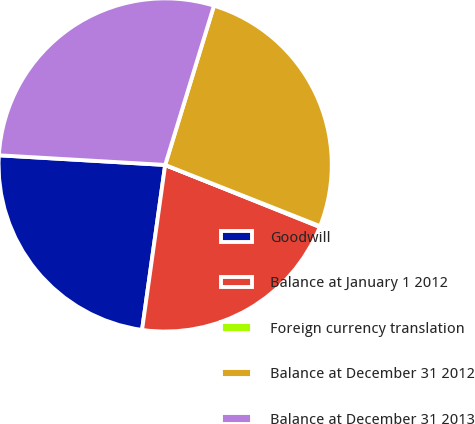<chart> <loc_0><loc_0><loc_500><loc_500><pie_chart><fcel>Goodwill<fcel>Balance at January 1 2012<fcel>Foreign currency translation<fcel>Balance at December 31 2012<fcel>Balance at December 31 2013<nl><fcel>23.71%<fcel>21.15%<fcel>0.08%<fcel>26.26%<fcel>28.81%<nl></chart> 